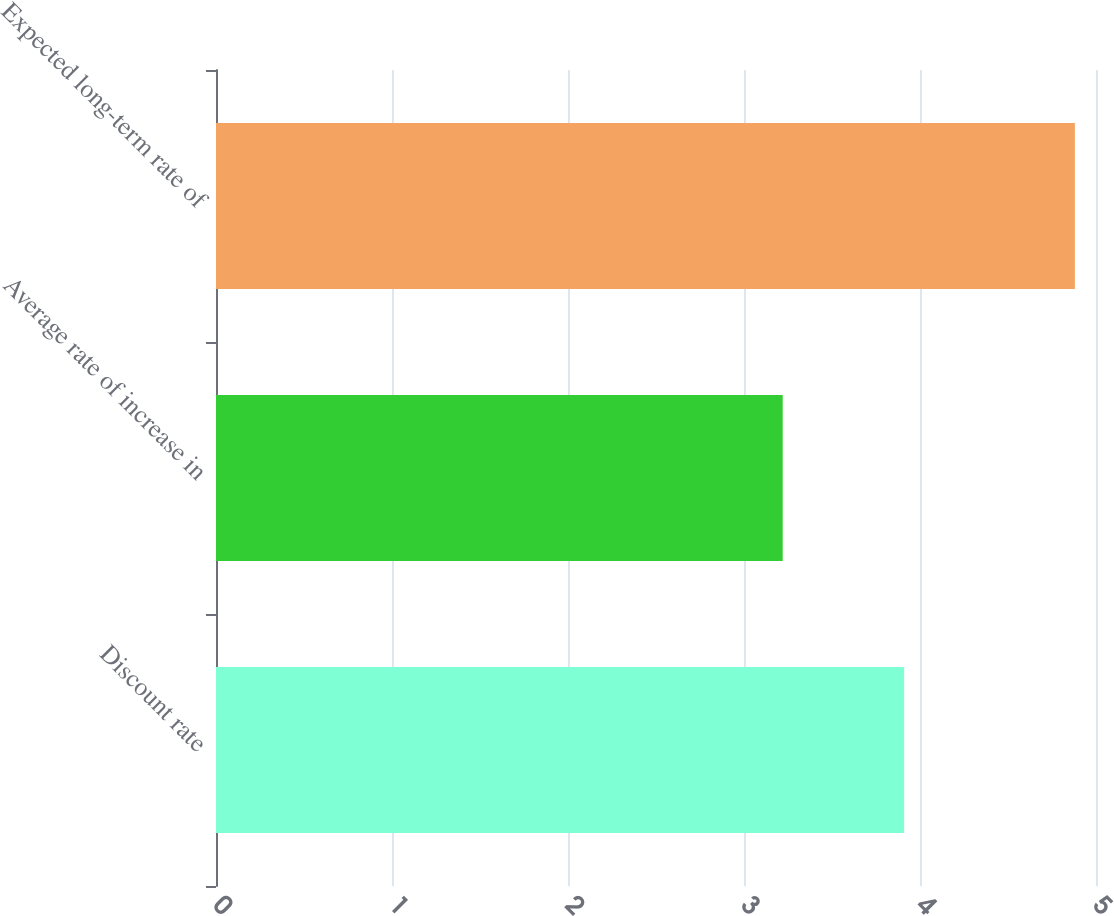Convert chart. <chart><loc_0><loc_0><loc_500><loc_500><bar_chart><fcel>Discount rate<fcel>Average rate of increase in<fcel>Expected long-term rate of<nl><fcel>3.91<fcel>3.22<fcel>4.88<nl></chart> 